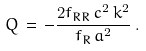Convert formula to latex. <formula><loc_0><loc_0><loc_500><loc_500>Q \, = \, - \frac { 2 f _ { R R } \, c ^ { 2 } \, k ^ { 2 } } { f _ { R } \, a ^ { 2 } } \, .</formula> 